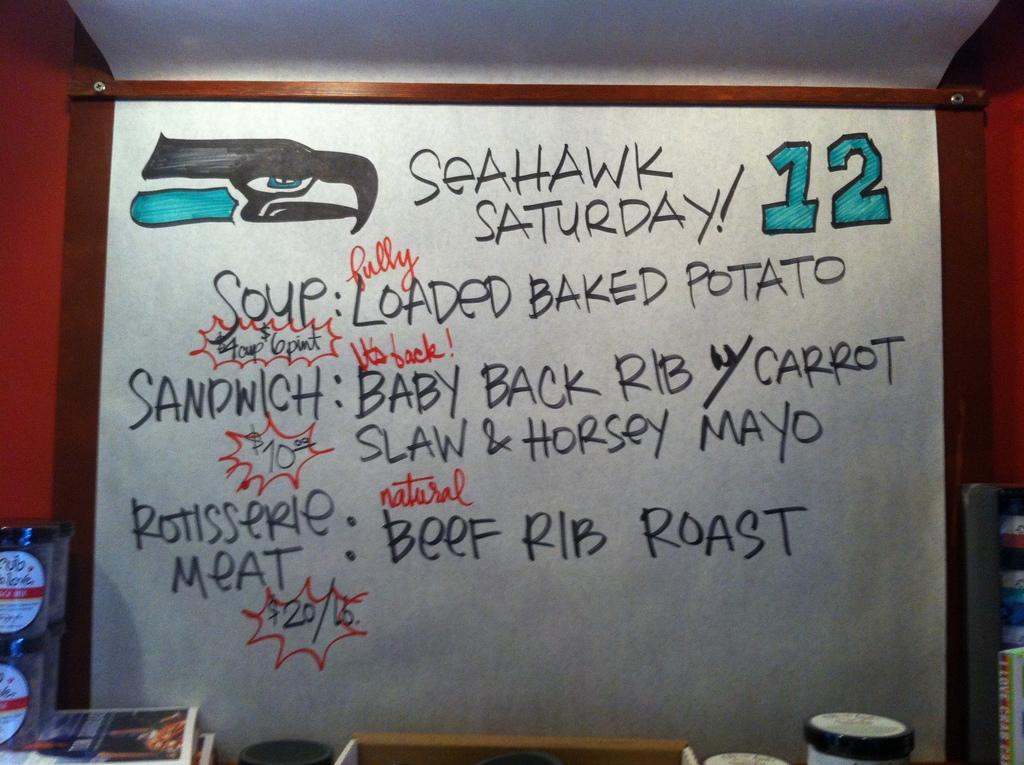<image>
Summarize the visual content of the image. The specials today are called Seahawk Saturday Specials 